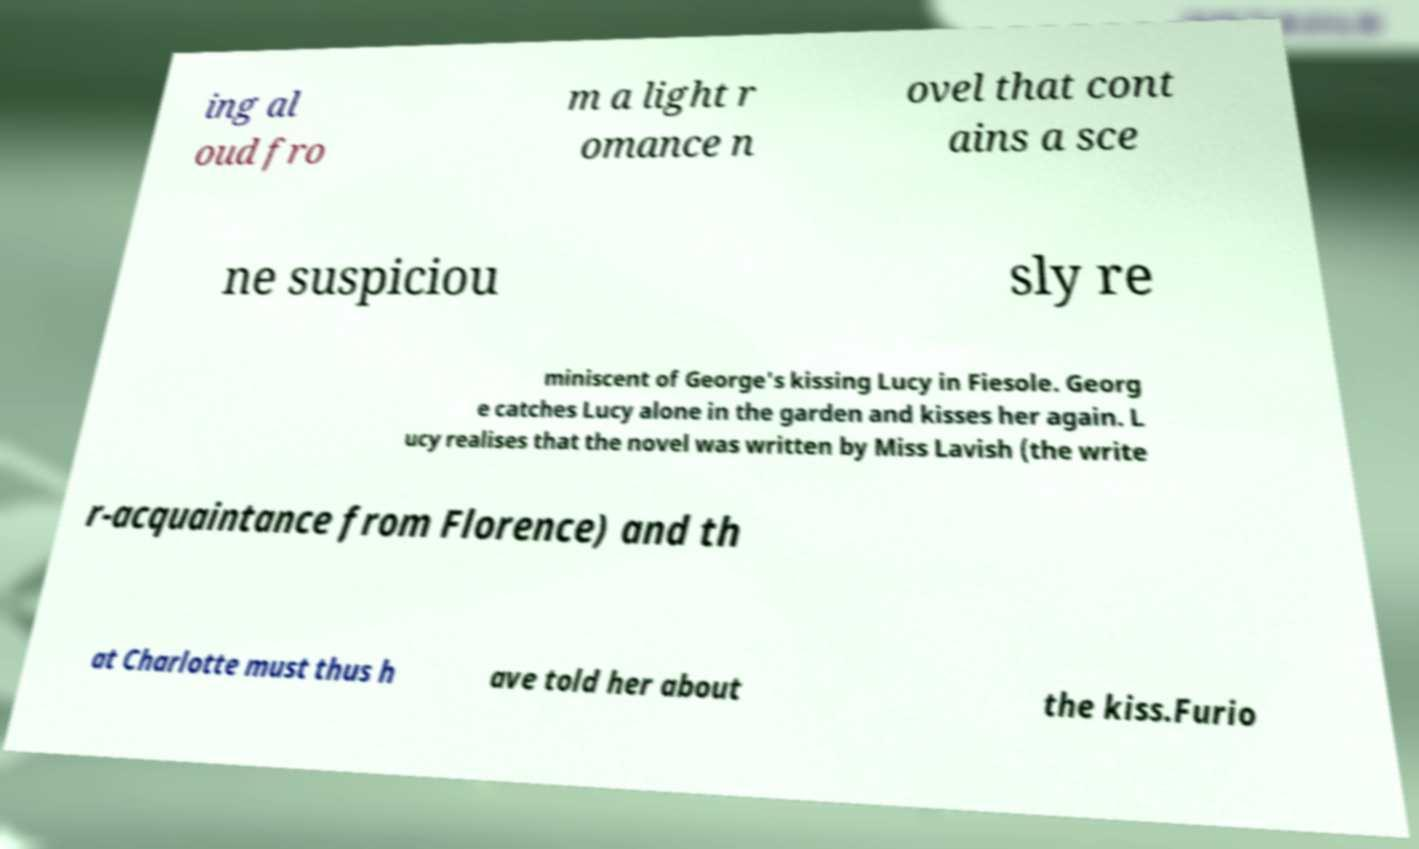Could you extract and type out the text from this image? ing al oud fro m a light r omance n ovel that cont ains a sce ne suspiciou sly re miniscent of George's kissing Lucy in Fiesole. Georg e catches Lucy alone in the garden and kisses her again. L ucy realises that the novel was written by Miss Lavish (the write r-acquaintance from Florence) and th at Charlotte must thus h ave told her about the kiss.Furio 